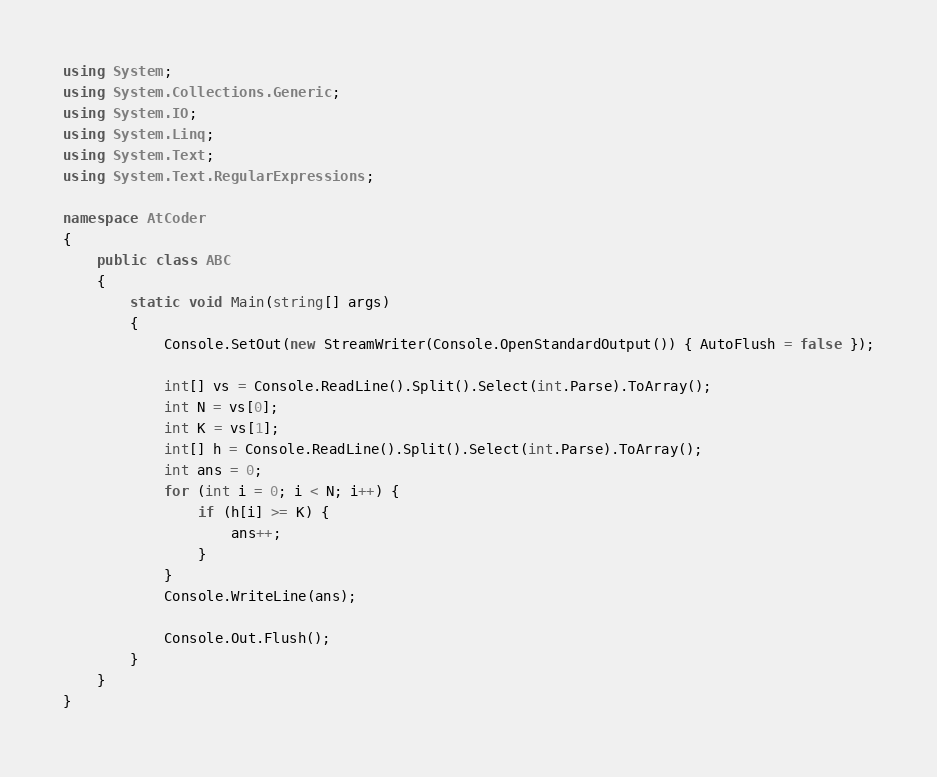Convert code to text. <code><loc_0><loc_0><loc_500><loc_500><_C#_>using System;
using System.Collections.Generic;
using System.IO;
using System.Linq;
using System.Text;
using System.Text.RegularExpressions;

namespace AtCoder
{
	public class ABC
	{
		static void Main(string[] args)
		{
			Console.SetOut(new StreamWriter(Console.OpenStandardOutput()) { AutoFlush = false });

            int[] vs = Console.ReadLine().Split().Select(int.Parse).ToArray();
            int N = vs[0];
            int K = vs[1];
            int[] h = Console.ReadLine().Split().Select(int.Parse).ToArray();
            int ans = 0;
            for (int i = 0; i < N; i++) {
                if (h[i] >= K) {
                    ans++;
                }
            }
            Console.WriteLine(ans);

            Console.Out.Flush();
		}
	}
}
</code> 